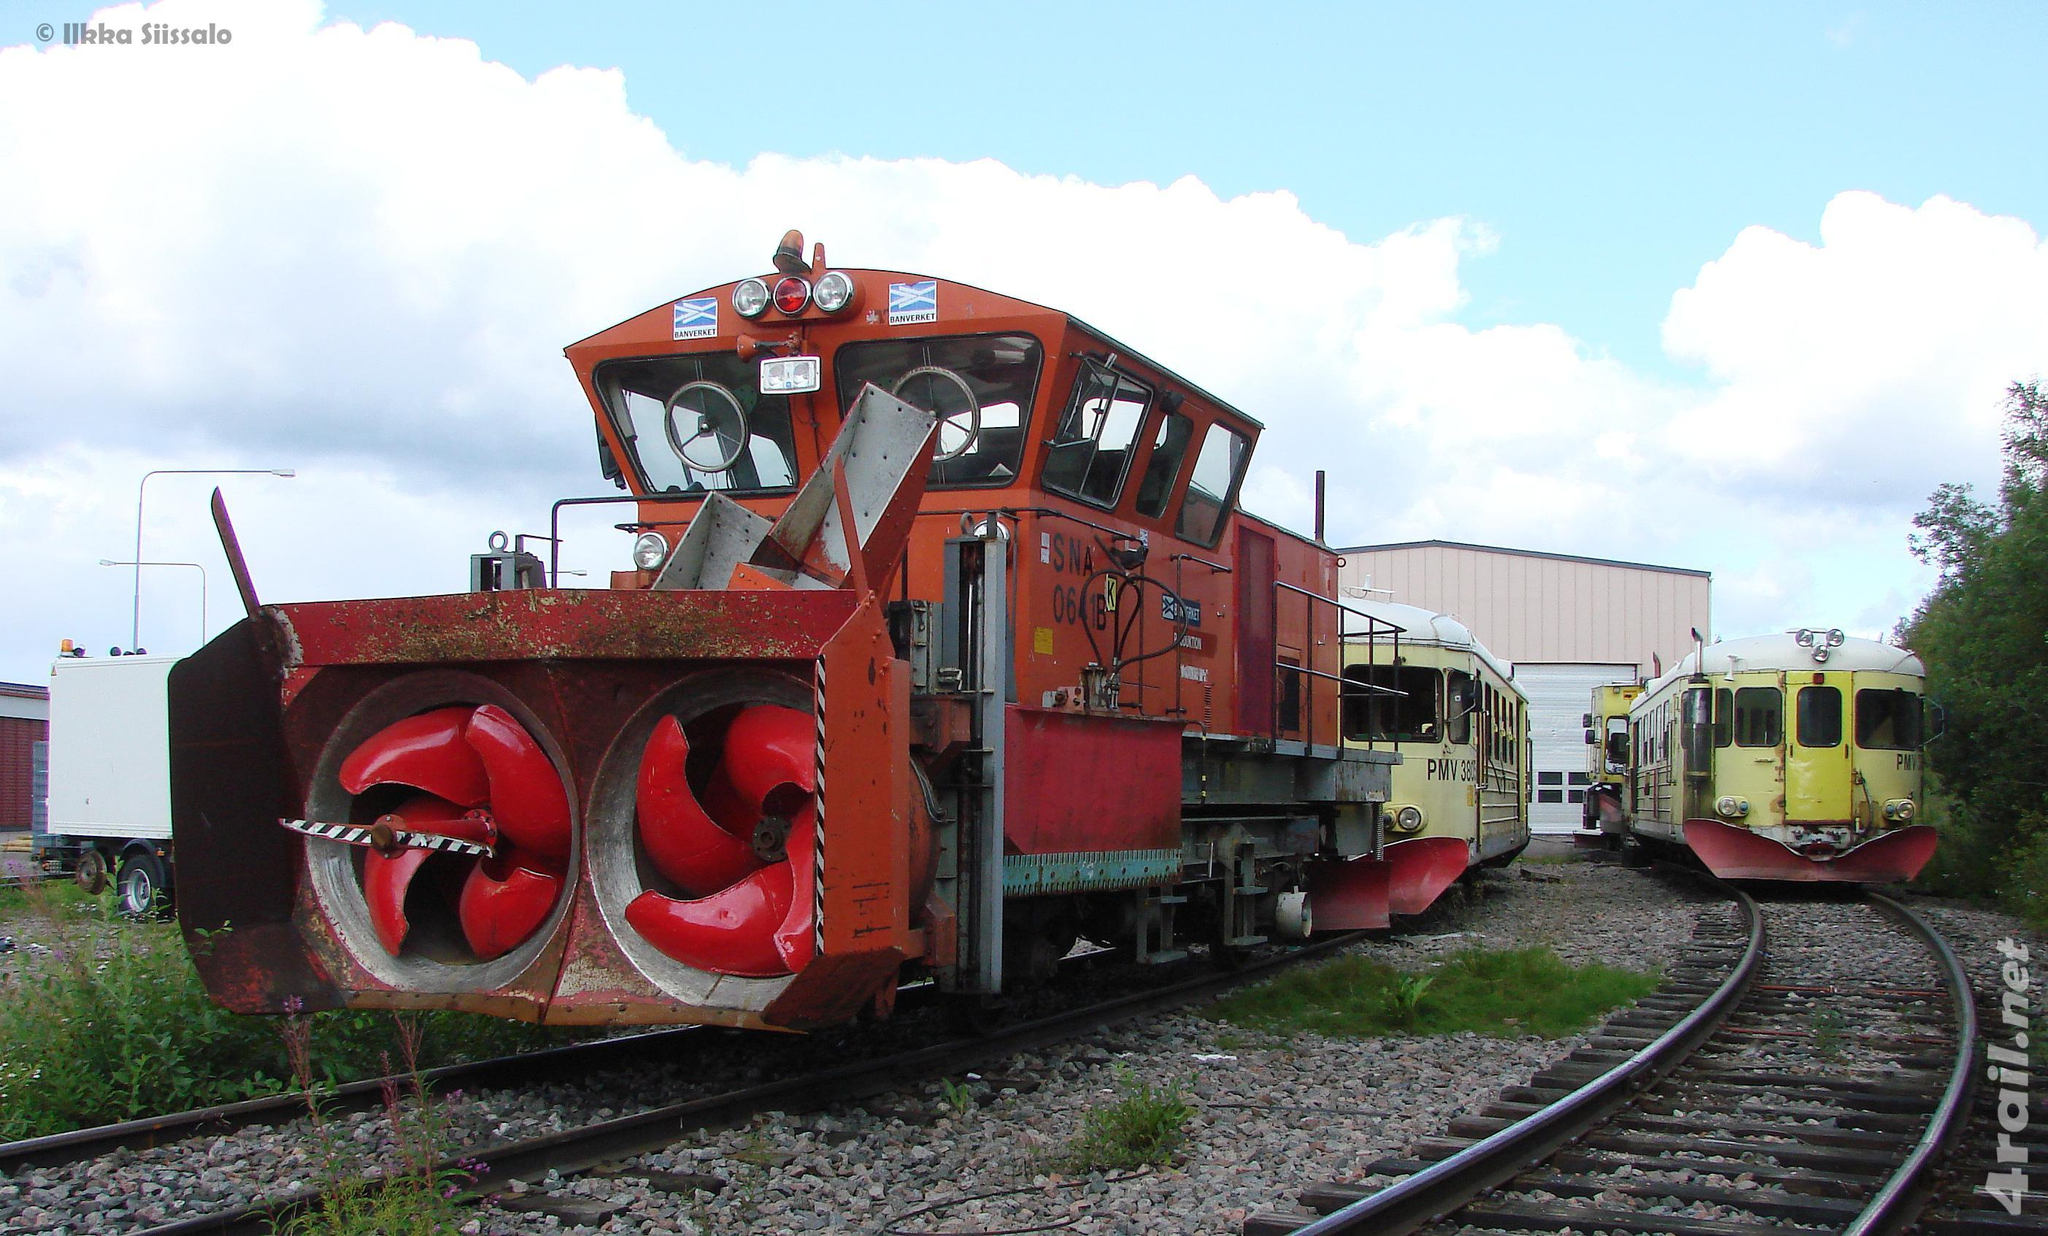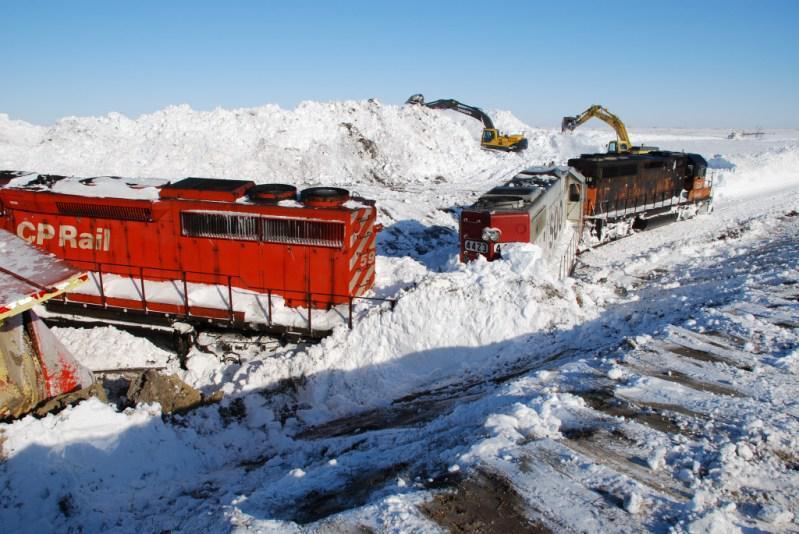The first image is the image on the left, the second image is the image on the right. Evaluate the accuracy of this statement regarding the images: "The left and right image contains the same number of black trains.". Is it true? Answer yes or no. No. The first image is the image on the left, the second image is the image on the right. Examine the images to the left and right. Is the description "Snow covers the area in each of the images." accurate? Answer yes or no. No. 